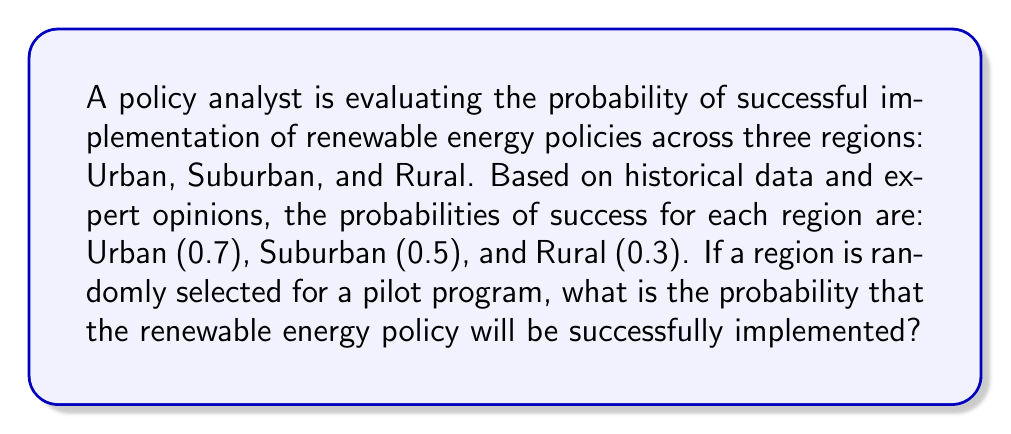Could you help me with this problem? To solve this problem, we need to use the concept of total probability. Let's break it down step-by-step:

1. Define the events:
   Let S be the event of successful implementation
   Let U, B, and R be the events of selecting Urban, Suburban, and Rural regions respectively

2. Given probabilities:
   P(S|U) = 0.7 (probability of success given Urban region)
   P(S|B) = 0.5 (probability of success given Suburban region)
   P(S|R) = 0.3 (probability of success given Rural region)

3. Assume equal probability of selecting each region:
   P(U) = P(B) = P(R) = $\frac{1}{3}$

4. Use the law of total probability:
   $$P(S) = P(S|U) \cdot P(U) + P(S|B) \cdot P(B) + P(S|R) \cdot P(R)$$

5. Substitute the values:
   $$P(S) = 0.7 \cdot \frac{1}{3} + 0.5 \cdot \frac{1}{3} + 0.3 \cdot \frac{1}{3}$$

6. Simplify:
   $$P(S) = \frac{0.7 + 0.5 + 0.3}{3} = \frac{1.5}{3} = 0.5$$

Therefore, the probability of successful implementation of the renewable energy policy when a region is randomly selected is 0.5 or 50%.
Answer: 0.5 